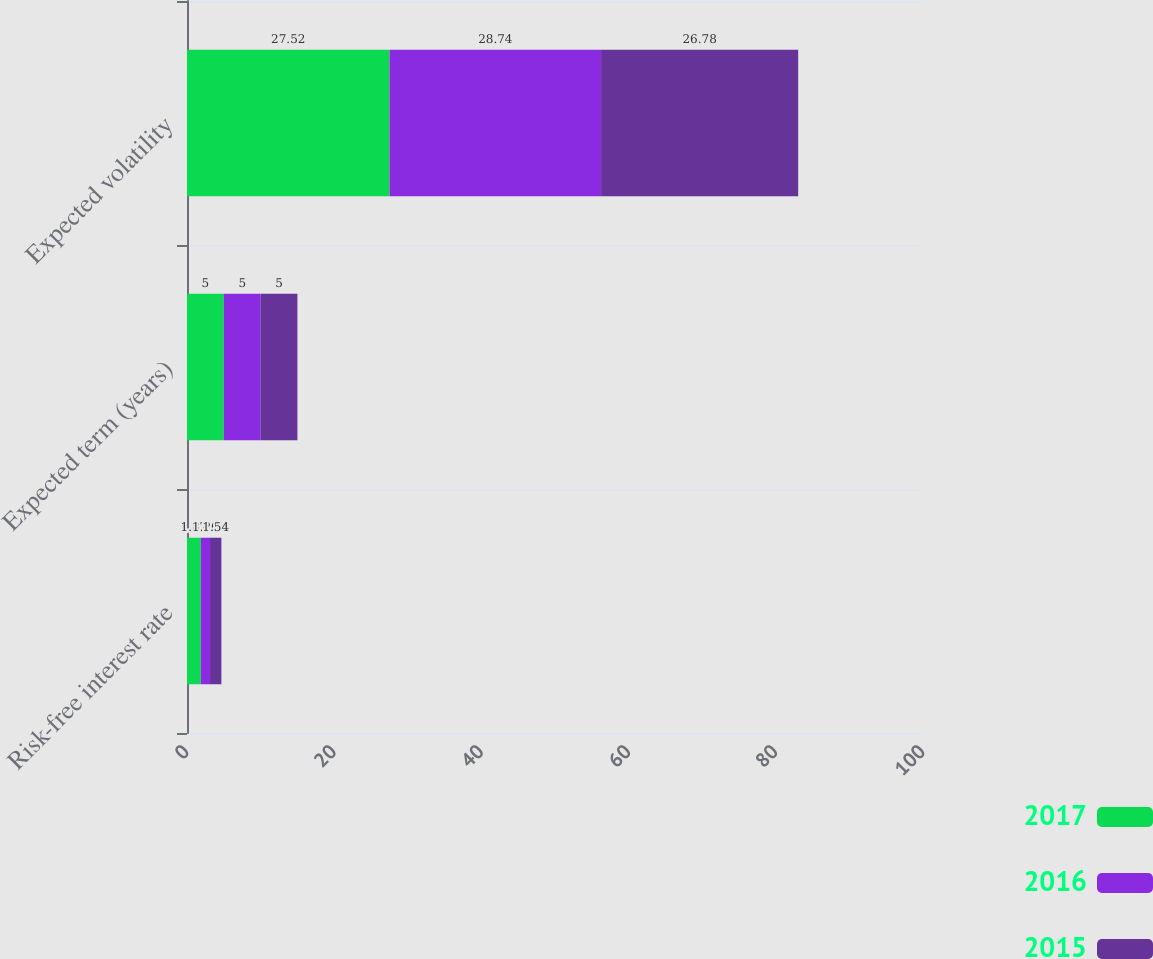Convert chart to OTSL. <chart><loc_0><loc_0><loc_500><loc_500><stacked_bar_chart><ecel><fcel>Risk-free interest rate<fcel>Expected term (years)<fcel>Expected volatility<nl><fcel>2017<fcel>1.87<fcel>5<fcel>27.52<nl><fcel>2016<fcel>1.26<fcel>5<fcel>28.74<nl><fcel>2015<fcel>1.54<fcel>5<fcel>26.78<nl></chart> 